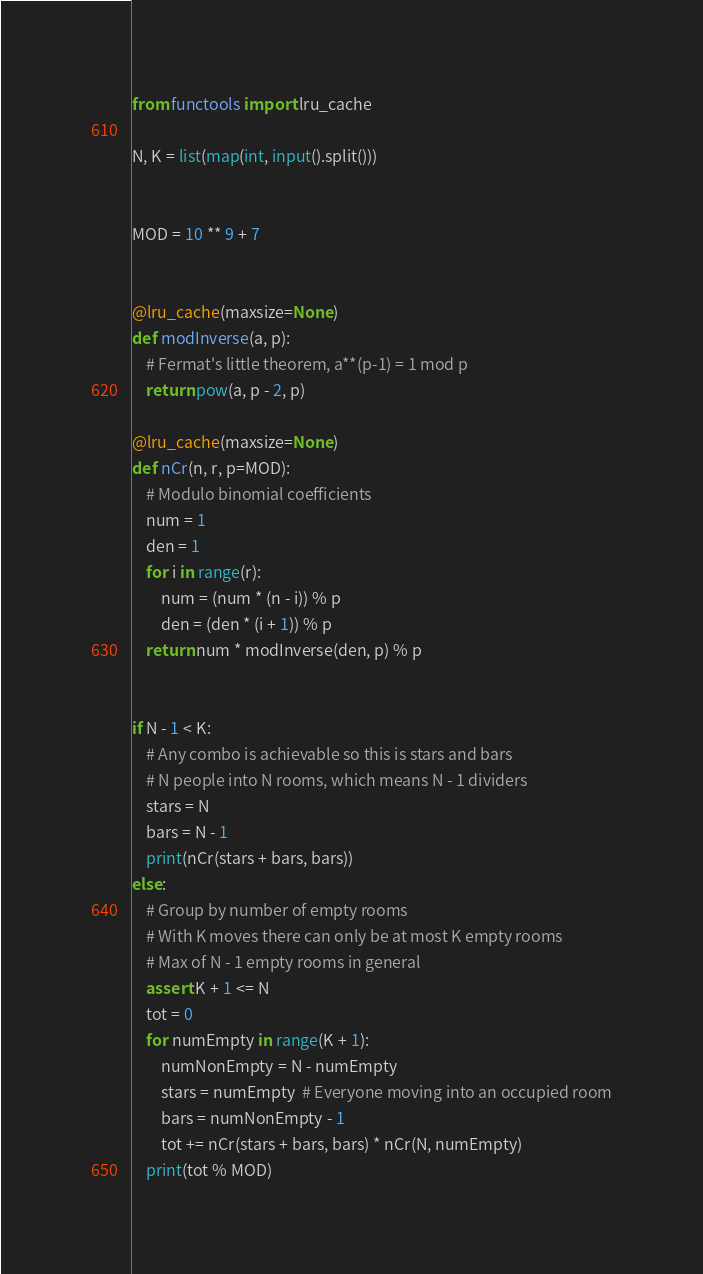Convert code to text. <code><loc_0><loc_0><loc_500><loc_500><_Python_>from functools import lru_cache

N, K = list(map(int, input().split()))


MOD = 10 ** 9 + 7


@lru_cache(maxsize=None)
def modInverse(a, p):
    # Fermat's little theorem, a**(p-1) = 1 mod p
    return pow(a, p - 2, p)

@lru_cache(maxsize=None)
def nCr(n, r, p=MOD):
    # Modulo binomial coefficients
    num = 1
    den = 1
    for i in range(r):
        num = (num * (n - i)) % p
        den = (den * (i + 1)) % p
    return num * modInverse(den, p) % p


if N - 1 < K:
    # Any combo is achievable so this is stars and bars
    # N people into N rooms, which means N - 1 dividers
    stars = N
    bars = N - 1
    print(nCr(stars + bars, bars))
else:
    # Group by number of empty rooms
    # With K moves there can only be at most K empty rooms
    # Max of N - 1 empty rooms in general
    assert K + 1 <= N
    tot = 0
    for numEmpty in range(K + 1):
        numNonEmpty = N - numEmpty
        stars = numEmpty  # Everyone moving into an occupied room
        bars = numNonEmpty - 1
        tot += nCr(stars + bars, bars) * nCr(N, numEmpty)
    print(tot % MOD)
</code> 